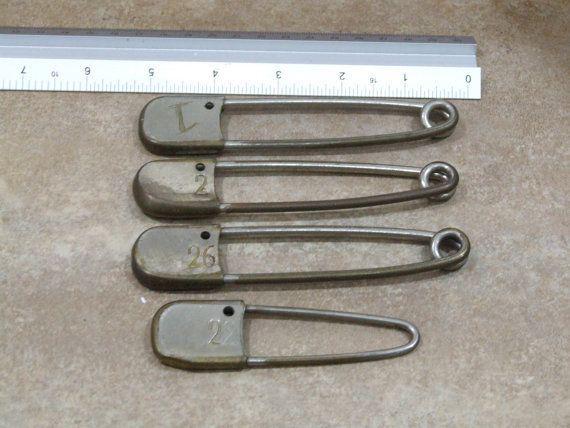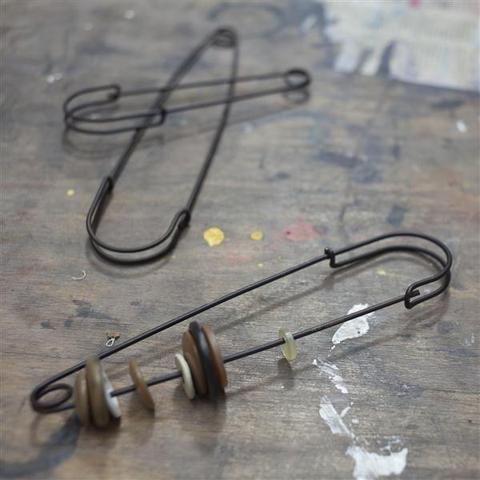The first image is the image on the left, the second image is the image on the right. Considering the images on both sides, is "The safety pins have numbers on them." valid? Answer yes or no. Yes. The first image is the image on the left, the second image is the image on the right. Given the left and right images, does the statement "One image contains exactly two gold-colored safety pins displayed horizontally." hold true? Answer yes or no. No. 